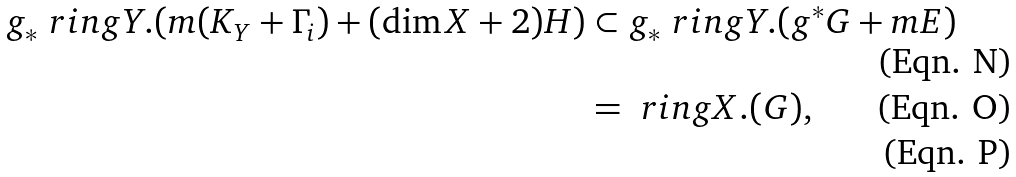Convert formula to latex. <formula><loc_0><loc_0><loc_500><loc_500>g _ { * } \ r i n g Y . ( m ( K _ { Y } + \Gamma _ { i } ) + ( \dim X + 2 ) H ) & \subset g _ { * } \ r i n g Y . ( g ^ { * } G + m E ) \\ & = \ r i n g X . ( G ) , \\</formula> 